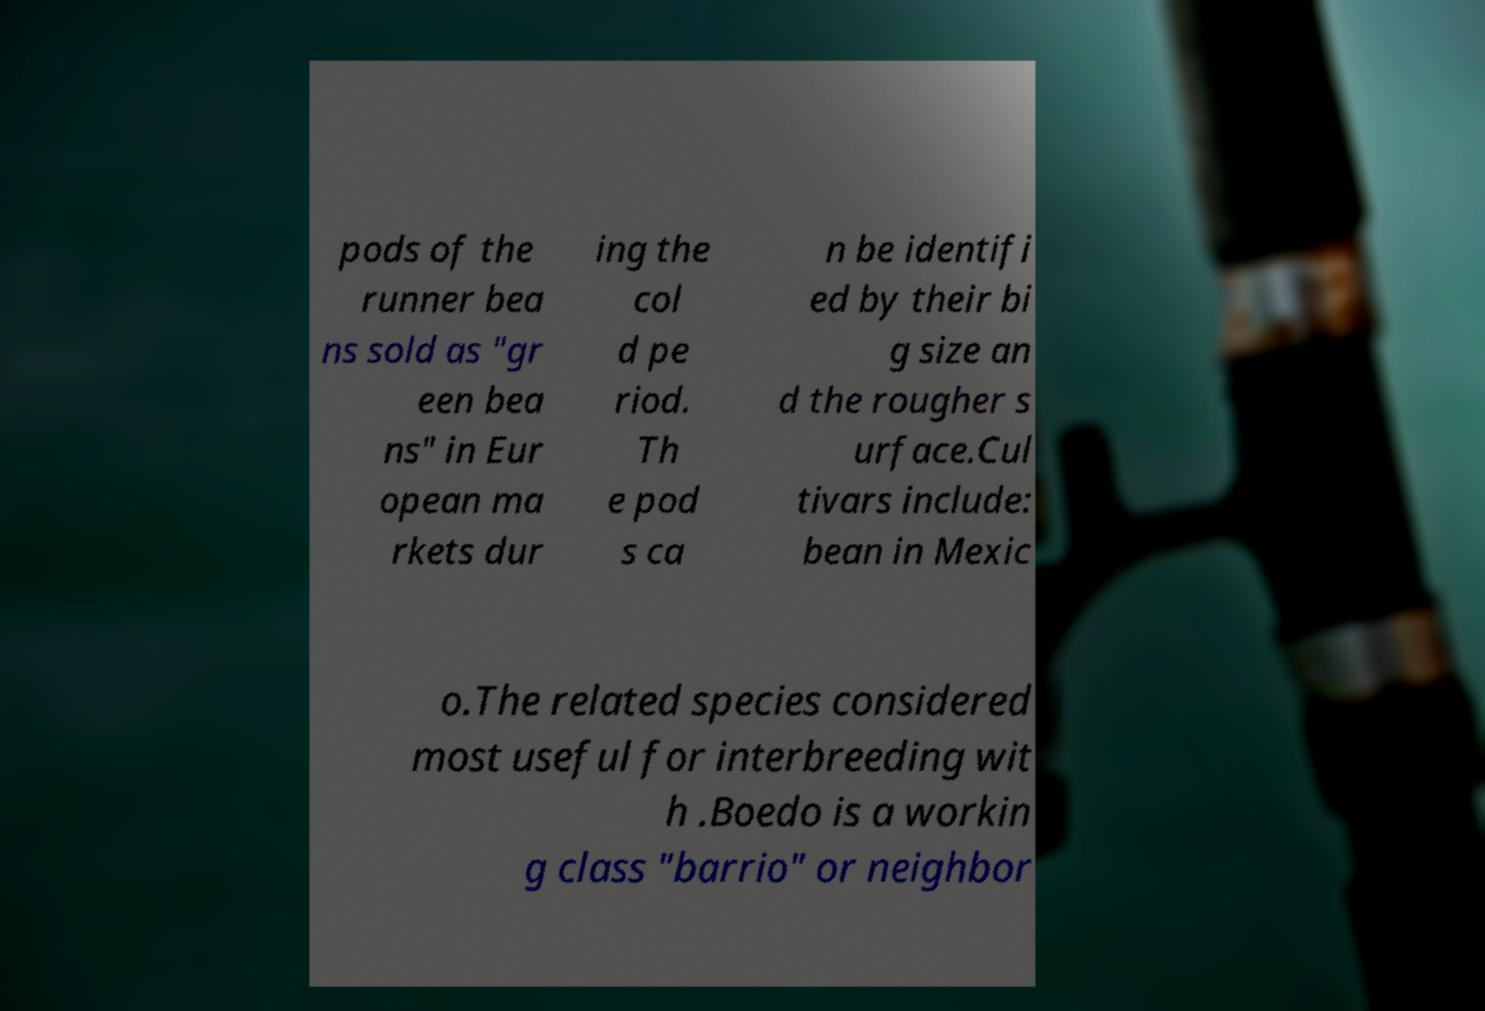I need the written content from this picture converted into text. Can you do that? pods of the runner bea ns sold as "gr een bea ns" in Eur opean ma rkets dur ing the col d pe riod. Th e pod s ca n be identifi ed by their bi g size an d the rougher s urface.Cul tivars include: bean in Mexic o.The related species considered most useful for interbreeding wit h .Boedo is a workin g class "barrio" or neighbor 